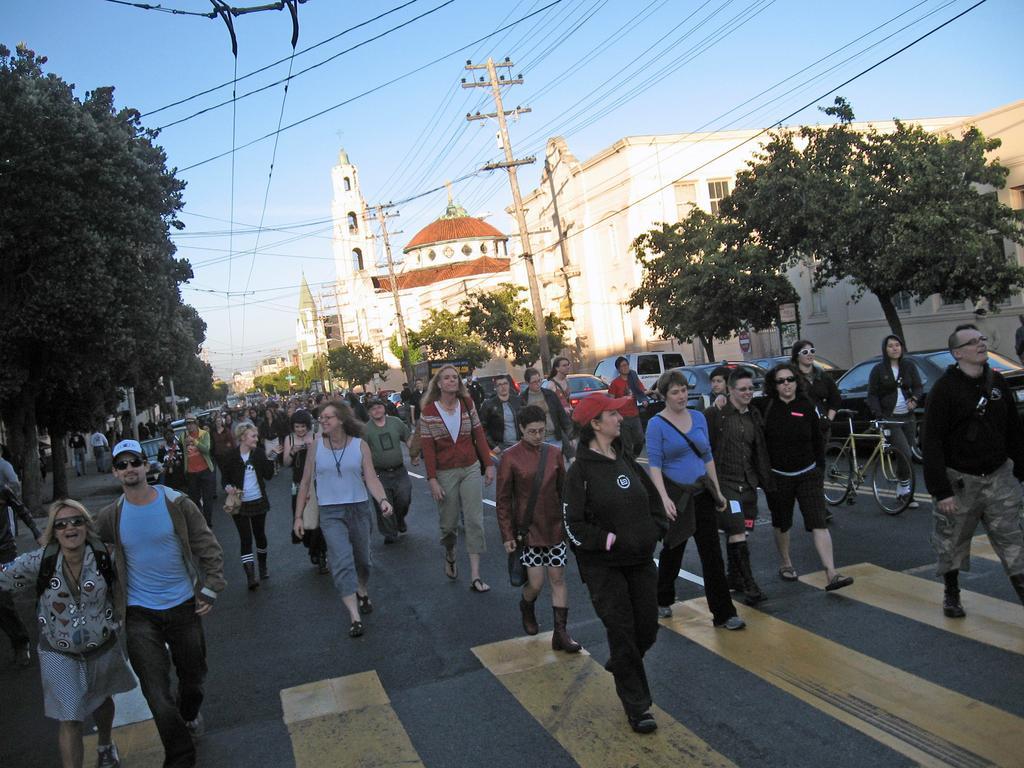Can you describe this image briefly? In the foreground I can see a crowd is walking on the road and I can see fleets of vehicles and bicycles. In the background I can see trees, buildings, light poles, wires, towers and the sky. This image is taken, may be during a day. 